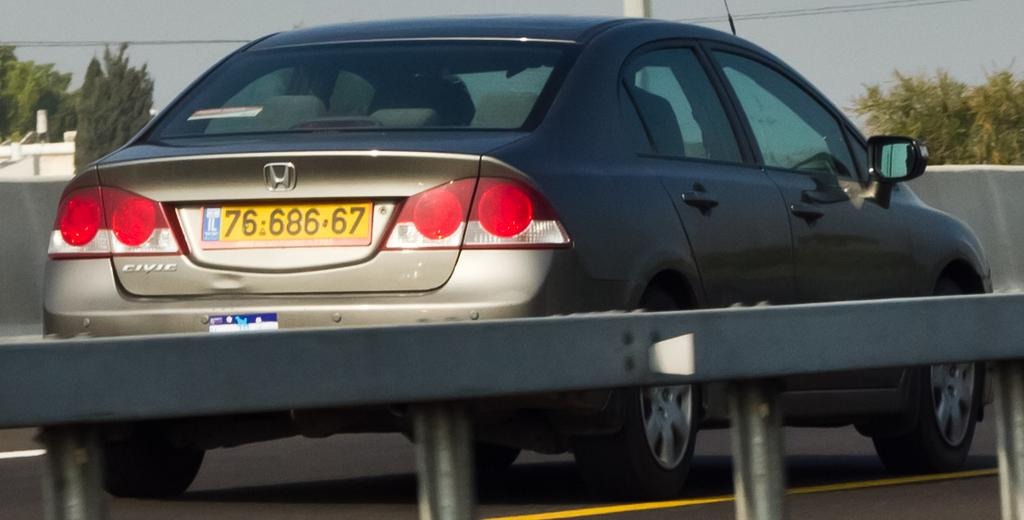Provide a one-sentence caption for the provided image. the numbers 76 that are on the back of a car. 